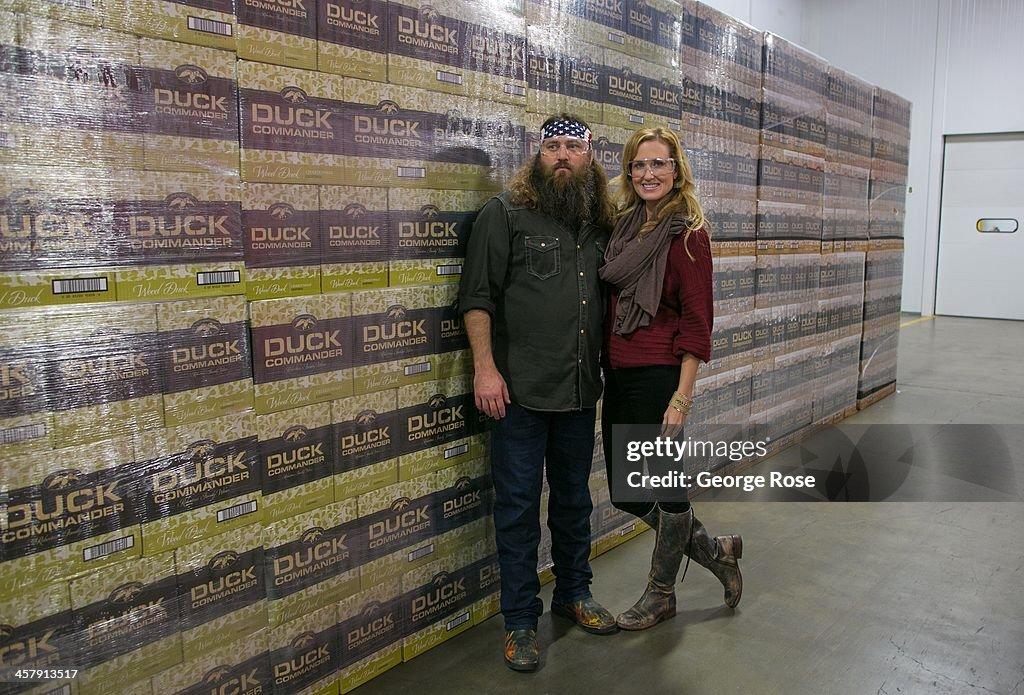Considering the branding on the boxes, what type of business or industry might the individuals be associated with? Given the presence of the 'DUCK COMMANDER' branding on the boxes, complete with a duck graphic, it is highly likely that the individuals are connected to the hunting industry, particularly focusing on duck hunting. Duck Commander is known for producing hunting-related products like duck calls, decoys, and other hunting gear. The individuals could be employees, owners, or promoters of this brand, standing proudly in front of a significant stockpile of their products, emphasizing their connection and dedication to the business. 